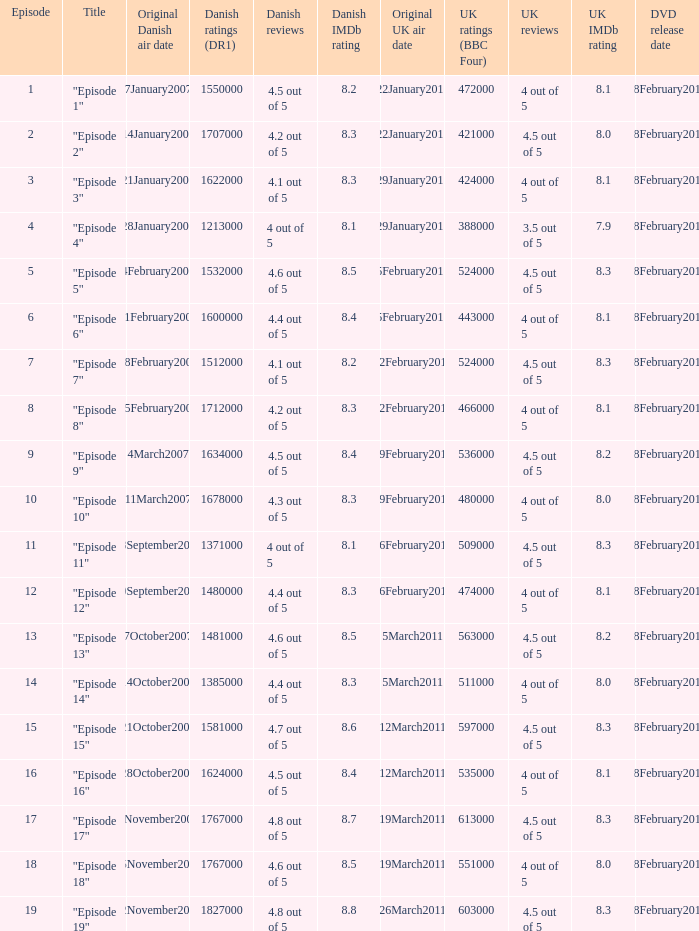What is the original Danish air date of "Episode 17"?  8November2007. Would you mind parsing the complete table? {'header': ['Episode', 'Title', 'Original Danish air date', 'Danish ratings (DR1)', 'Danish reviews', 'Danish IMDb rating', 'Original UK air date', 'UK ratings (BBC Four)', 'UK reviews', 'UK IMDb rating', 'DVD release date'], 'rows': [['1', '"Episode 1"', '7January2007', '1550000', '4.5 out of 5', '8.2', '22January2011', '472000', '4 out of 5', '8.1', '28February2012'], ['2', '"Episode 2"', '14January2007', '1707000', '4.2 out of 5', '8.3', '22January2011', '421000', '4.5 out of 5', '8.0', '28February2012'], ['3', '"Episode 3"', '21January2007', '1622000', '4.1 out of 5', '8.3', '29January2011', '424000', '4 out of 5', '8.1', '28February2012'], ['4', '"Episode 4"', '28January2007', '1213000', '4 out of 5', '8.1', '29January2011', '388000', '3.5 out of 5', '7.9', '28February2012'], ['5', '"Episode 5"', '4February2007', '1532000', '4.6 out of 5', '8.5', '5February2011', '524000', '4.5 out of 5', '8.3', '28February2012'], ['6', '"Episode 6"', '11February2007', '1600000', '4.4 out of 5', '8.4', '5February2011', '443000', '4 out of 5', '8.1', '28February2012'], ['7', '"Episode 7"', '18February2007', '1512000', '4.1 out of 5', '8.2', '12February2011', '524000', '4.5 out of 5', '8.3', '28February2012'], ['8', '"Episode 8"', '25February2007', '1712000', '4.2 out of 5', '8.3', '12February2011', '466000', '4 out of 5', '8.1', '28February2012'], ['9', '"Episode 9"', '4March2007', '1634000', '4.5 out of 5', '8.4', '19February2011', '536000', '4.5 out of 5', '8.2', '28February2012'], ['10', '"Episode 10"', '11March2007', '1678000', '4.3 out of 5', '8.3', '19February2011', '480000', '4 out of 5', '8.0', '28February2012'], ['11', '"Episode 11"', '23September2007', '1371000', '4 out of 5', '8.1', '26February2011', '509000', '4.5 out of 5', '8.3', '28February2012'], ['12', '"Episode 12"', '30September2007', '1480000', '4.4 out of 5', '8.3', '26February2011', '474000', '4 out of 5', '8.1', '28February2012'], ['13', '"Episode 13"', '7October2007', '1481000', '4.6 out of 5', '8.5', '5March2011', '563000', '4.5 out of 5', '8.2', '28February2012'], ['14', '"Episode 14"', '14October2007', '1385000', '4.4 out of 5', '8.3', '5March2011', '511000', '4 out of 5', '8.0', '28February2012'], ['15', '"Episode 15"', '21October2007', '1581000', '4.7 out of 5', '8.6', '12March2011', '597000', '4.5 out of 5', '8.3', '28February2012'], ['16', '"Episode 16"', '28October2007', '1624000', '4.5 out of 5', '8.4', '12March2011', '535000', '4 out of 5', '8.1', '28February2012'], ['17', '"Episode 17"', '8November2007', '1767000', '4.8 out of 5', '8.7', '19March2011', '613000', '4.5 out of 5', '8.3', '28February2012'], ['18', '"Episode 18"', '15November2007', '1767000', '4.6 out of 5', '8.5', '19March2011', '551000', '4 out of 5', '8.0', '28February2012'], ['19', '"Episode 19"', '22November2007', '1827000', '4.8 out of 5', '8.8', '26March2011', '603000', '4.5 out of 5', '8.3', '28February2012']]} 